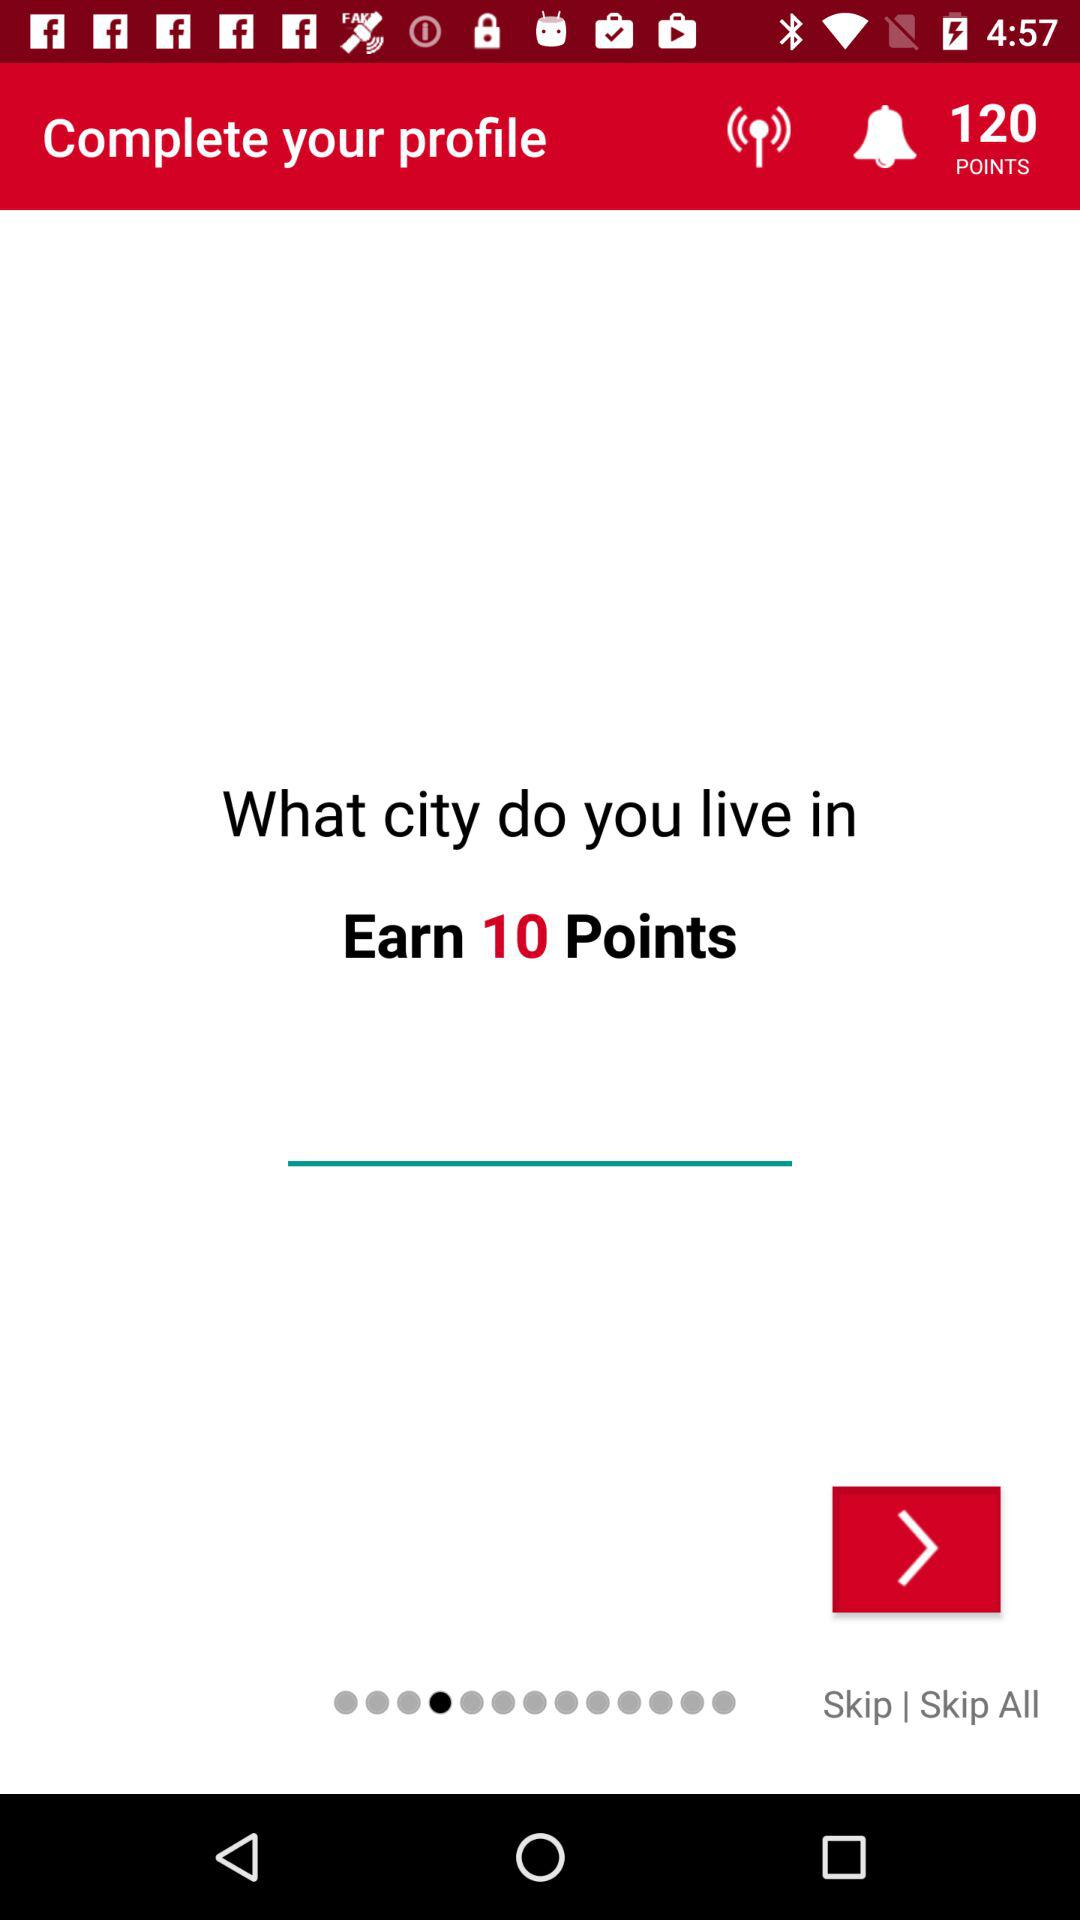How many points can be earned by entering the name of the city? You can earn 10 points. 